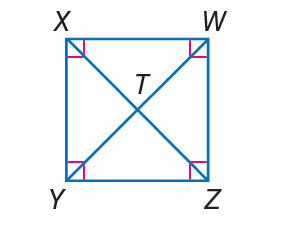Answer the mathemtical geometry problem and directly provide the correct option letter.
Question: W X Y Z is a square. If W T = 3, find Z X.
Choices: A: 3 B: 5 C: 6 D: 9 C 